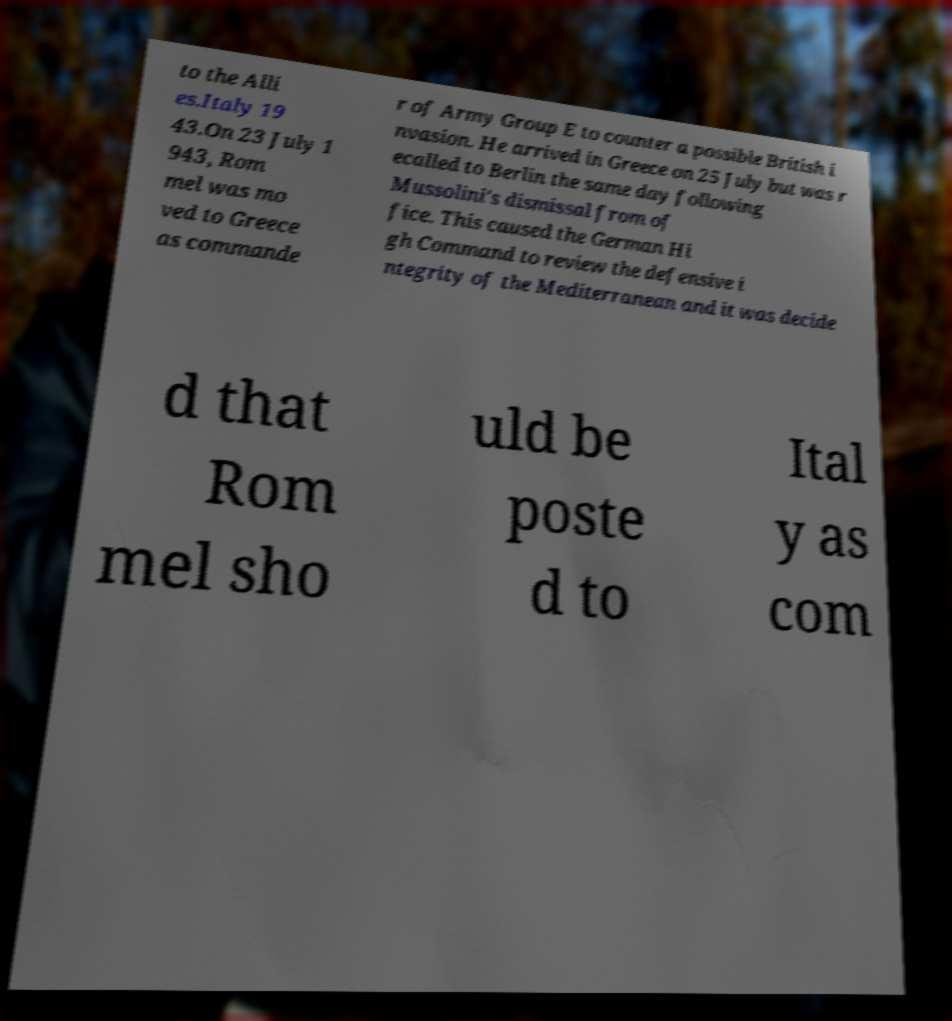Can you read and provide the text displayed in the image?This photo seems to have some interesting text. Can you extract and type it out for me? to the Alli es.Italy 19 43.On 23 July 1 943, Rom mel was mo ved to Greece as commande r of Army Group E to counter a possible British i nvasion. He arrived in Greece on 25 July but was r ecalled to Berlin the same day following Mussolini's dismissal from of fice. This caused the German Hi gh Command to review the defensive i ntegrity of the Mediterranean and it was decide d that Rom mel sho uld be poste d to Ital y as com 